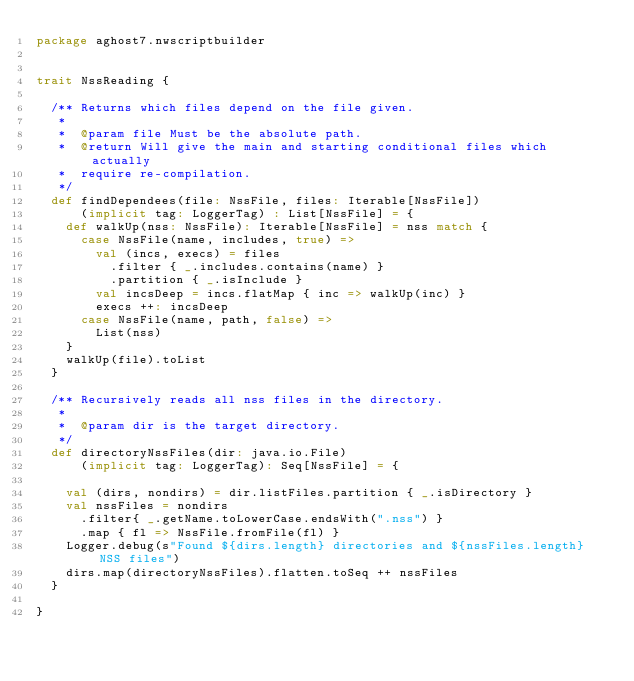<code> <loc_0><loc_0><loc_500><loc_500><_Scala_>package aghost7.nwscriptbuilder


trait NssReading {

	/** Returns which files depend on the file given.
	 *  
	 *  @param file Must be the absolute path.
	 *  @return Will give the main and starting conditional files which actually
	 *  require re-compilation.
	 */
	def findDependees(file: NssFile, files: Iterable[NssFile])
			(implicit tag: LoggerTag) : List[NssFile] = {
		def walkUp(nss: NssFile): Iterable[NssFile] = nss match {
			case NssFile(name, includes, true) =>
				val (incs, execs) = files
					.filter { _.includes.contains(name) }
					.partition { _.isInclude }
				val incsDeep = incs.flatMap { inc => walkUp(inc) }
				execs ++: incsDeep
			case NssFile(name, path, false) =>
				List(nss)
		}
		walkUp(file).toList
	}
	
	/** Recursively reads all nss files in the directory.
	 *  
	 *  @param dir is the target directory.
	 */
	def directoryNssFiles(dir: java.io.File)
			(implicit tag: LoggerTag): Seq[NssFile] = {

		val (dirs, nondirs) = dir.listFiles.partition { _.isDirectory }
		val nssFiles = nondirs
			.filter{ _.getName.toLowerCase.endsWith(".nss") }
			.map { fl => NssFile.fromFile(fl) }
		Logger.debug(s"Found ${dirs.length} directories and ${nssFiles.length} NSS files")
		dirs.map(directoryNssFiles).flatten.toSeq ++ nssFiles
	}
	
}</code> 